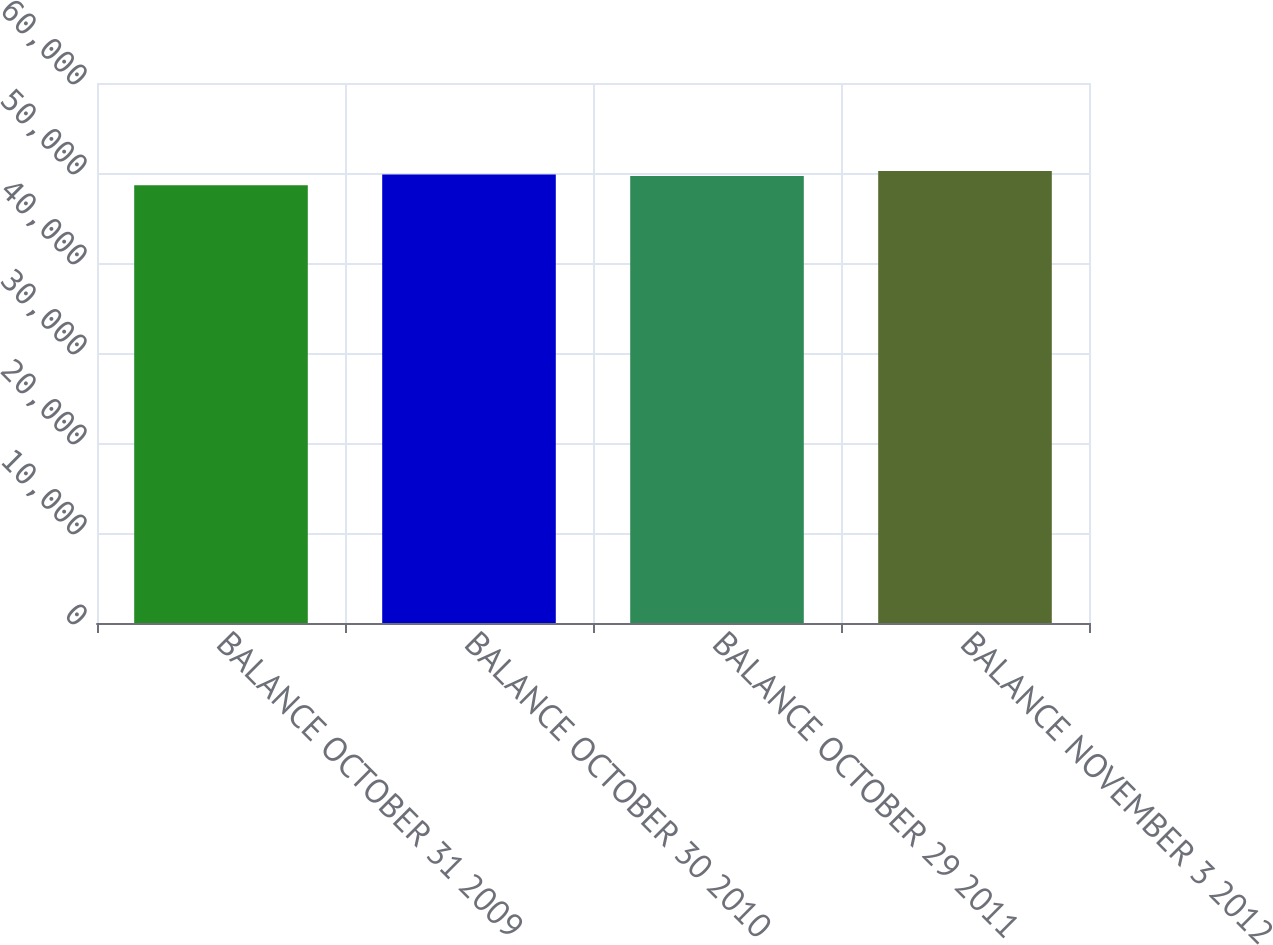<chart> <loc_0><loc_0><loc_500><loc_500><bar_chart><fcel>BALANCE OCTOBER 31 2009<fcel>BALANCE OCTOBER 30 2010<fcel>BALANCE OCTOBER 29 2011<fcel>BALANCE NOVEMBER 3 2012<nl><fcel>48645<fcel>49819.8<fcel>49661<fcel>50233<nl></chart> 